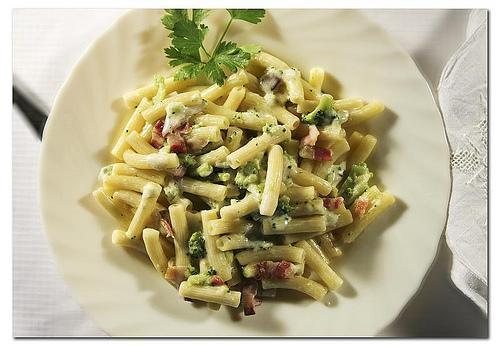How many people are laying down?
Give a very brief answer. 0. 